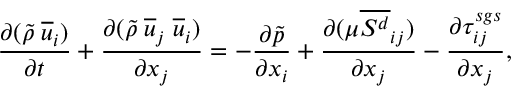Convert formula to latex. <formula><loc_0><loc_0><loc_500><loc_500>\frac { \partial ( \tilde { \rho } \, \overline { u } _ { i } ) } { \partial t } + \frac { \partial ( \tilde { \rho } \, \overline { u } _ { j } \, \overline { u } _ { i } ) } { \partial x _ { j } } = - \frac { \partial \tilde { p } } { \partial x _ { i } } + \frac { \partial ( \mu \overline { { S ^ { d } } } _ { i j } ) } { \partial x _ { j } } - \frac { \partial \tau _ { i j } ^ { s g s } } { \partial x _ { j } } ,</formula> 